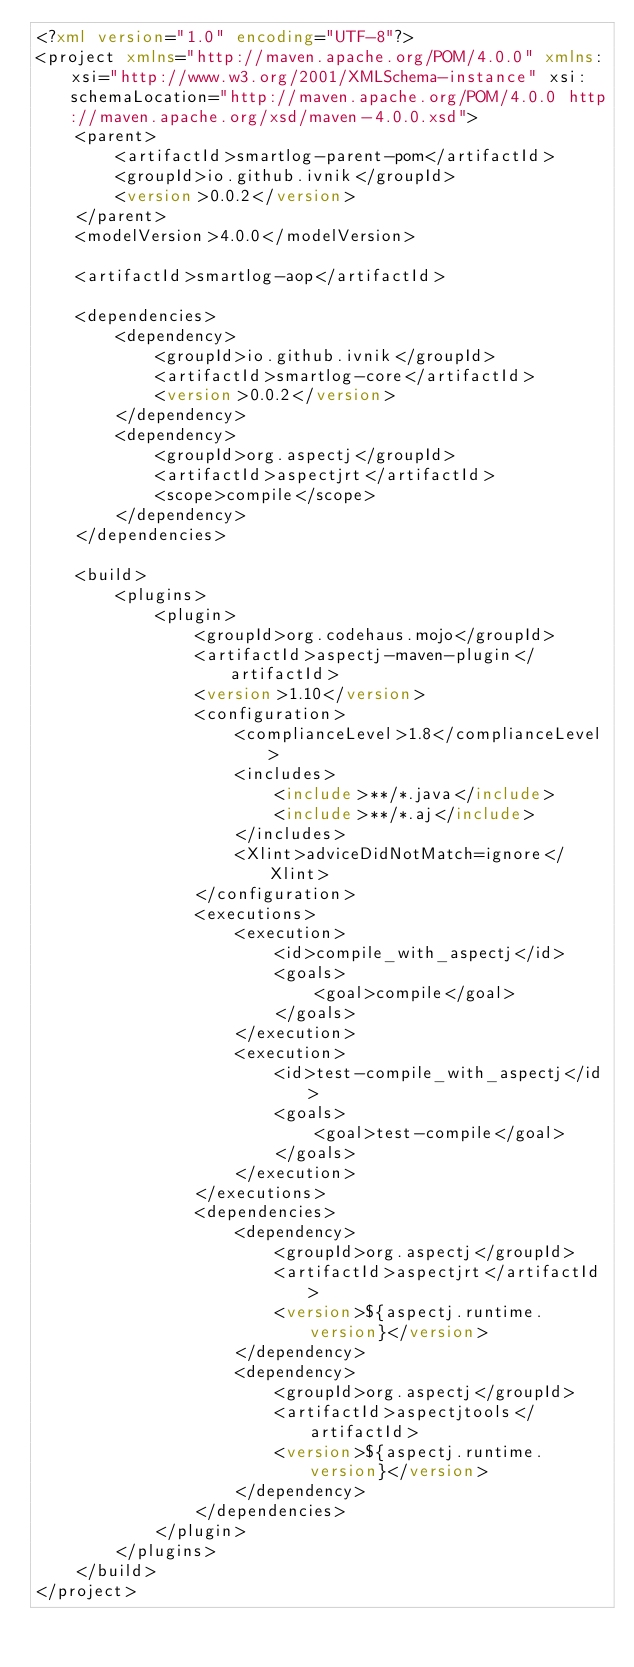<code> <loc_0><loc_0><loc_500><loc_500><_XML_><?xml version="1.0" encoding="UTF-8"?>
<project xmlns="http://maven.apache.org/POM/4.0.0" xmlns:xsi="http://www.w3.org/2001/XMLSchema-instance" xsi:schemaLocation="http://maven.apache.org/POM/4.0.0 http://maven.apache.org/xsd/maven-4.0.0.xsd">
    <parent>
        <artifactId>smartlog-parent-pom</artifactId>
        <groupId>io.github.ivnik</groupId>
        <version>0.0.2</version>
    </parent>
    <modelVersion>4.0.0</modelVersion>

    <artifactId>smartlog-aop</artifactId>

    <dependencies>
        <dependency>
            <groupId>io.github.ivnik</groupId>
            <artifactId>smartlog-core</artifactId>
            <version>0.0.2</version>
        </dependency>
        <dependency>
            <groupId>org.aspectj</groupId>
            <artifactId>aspectjrt</artifactId>
            <scope>compile</scope>
        </dependency>
    </dependencies>

    <build>
        <plugins>
            <plugin>
                <groupId>org.codehaus.mojo</groupId>
                <artifactId>aspectj-maven-plugin</artifactId>
                <version>1.10</version>
                <configuration>
                    <complianceLevel>1.8</complianceLevel>
                    <includes>
                        <include>**/*.java</include>
                        <include>**/*.aj</include>
                    </includes>
                    <Xlint>adviceDidNotMatch=ignore</Xlint>
                </configuration>
                <executions>
                    <execution>
                        <id>compile_with_aspectj</id>
                        <goals>
                            <goal>compile</goal>
                        </goals>
                    </execution>
                    <execution>
                        <id>test-compile_with_aspectj</id>
                        <goals>
                            <goal>test-compile</goal>
                        </goals>
                    </execution>
                </executions>
                <dependencies>
                    <dependency>
                        <groupId>org.aspectj</groupId>
                        <artifactId>aspectjrt</artifactId>
                        <version>${aspectj.runtime.version}</version>
                    </dependency>
                    <dependency>
                        <groupId>org.aspectj</groupId>
                        <artifactId>aspectjtools</artifactId>
                        <version>${aspectj.runtime.version}</version>
                    </dependency>
                </dependencies>
            </plugin>
        </plugins>
    </build>
</project></code> 